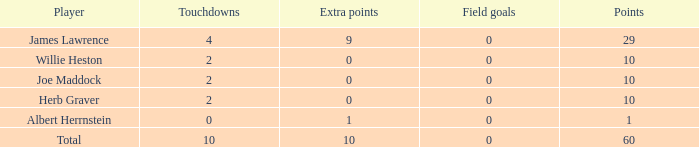What is the least number of field goals for participants with 4 touchdowns and under 9 extra points? None. 